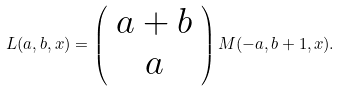<formula> <loc_0><loc_0><loc_500><loc_500>L ( a , b , x ) = \left ( \begin{array} { c } a + b \\ a \end{array} \right ) M ( - a , b + 1 , x ) .</formula> 